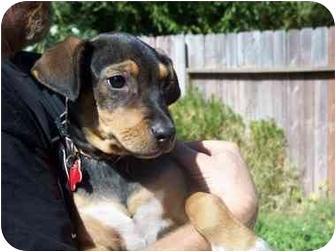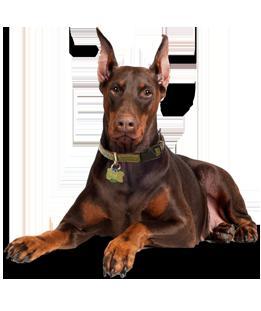The first image is the image on the left, the second image is the image on the right. For the images shown, is this caption "One Doberman's ears are both raised." true? Answer yes or no. Yes. The first image is the image on the left, the second image is the image on the right. Examine the images to the left and right. Is the description "The right image shows a forward-facing reclining two-tone adult doberman with erect pointy ears." accurate? Answer yes or no. Yes. 